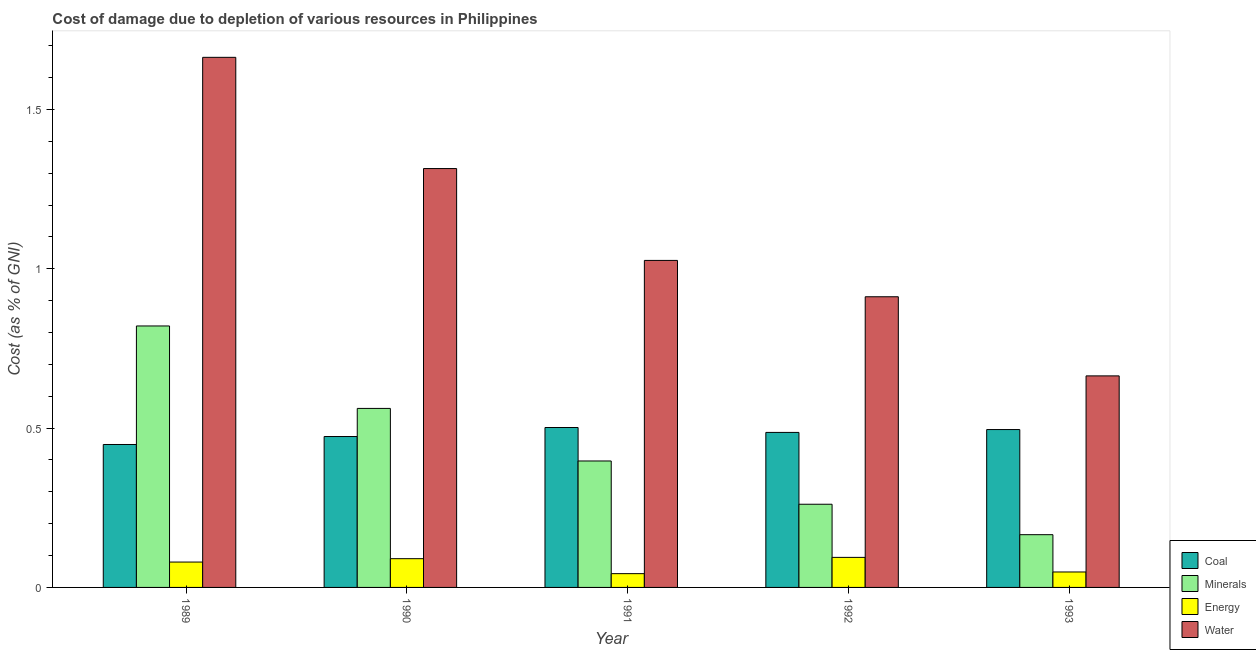How many groups of bars are there?
Your answer should be compact. 5. Are the number of bars per tick equal to the number of legend labels?
Offer a very short reply. Yes. How many bars are there on the 2nd tick from the left?
Ensure brevity in your answer.  4. What is the label of the 1st group of bars from the left?
Provide a succinct answer. 1989. What is the cost of damage due to depletion of energy in 1989?
Provide a succinct answer. 0.08. Across all years, what is the maximum cost of damage due to depletion of minerals?
Offer a very short reply. 0.82. Across all years, what is the minimum cost of damage due to depletion of energy?
Offer a very short reply. 0.04. What is the total cost of damage due to depletion of coal in the graph?
Give a very brief answer. 2.41. What is the difference between the cost of damage due to depletion of coal in 1989 and that in 1993?
Give a very brief answer. -0.05. What is the difference between the cost of damage due to depletion of water in 1992 and the cost of damage due to depletion of coal in 1989?
Keep it short and to the point. -0.75. What is the average cost of damage due to depletion of coal per year?
Give a very brief answer. 0.48. What is the ratio of the cost of damage due to depletion of water in 1991 to that in 1992?
Your answer should be very brief. 1.13. Is the cost of damage due to depletion of water in 1989 less than that in 1992?
Offer a very short reply. No. Is the difference between the cost of damage due to depletion of coal in 1990 and 1992 greater than the difference between the cost of damage due to depletion of energy in 1990 and 1992?
Offer a terse response. No. What is the difference between the highest and the second highest cost of damage due to depletion of coal?
Keep it short and to the point. 0.01. What is the difference between the highest and the lowest cost of damage due to depletion of water?
Provide a succinct answer. 1. In how many years, is the cost of damage due to depletion of minerals greater than the average cost of damage due to depletion of minerals taken over all years?
Give a very brief answer. 2. What does the 1st bar from the left in 1990 represents?
Offer a very short reply. Coal. What does the 4th bar from the right in 1992 represents?
Give a very brief answer. Coal. Is it the case that in every year, the sum of the cost of damage due to depletion of coal and cost of damage due to depletion of minerals is greater than the cost of damage due to depletion of energy?
Offer a very short reply. Yes. How many years are there in the graph?
Keep it short and to the point. 5. Does the graph contain grids?
Provide a succinct answer. No. How many legend labels are there?
Offer a very short reply. 4. How are the legend labels stacked?
Give a very brief answer. Vertical. What is the title of the graph?
Your answer should be very brief. Cost of damage due to depletion of various resources in Philippines . Does "Switzerland" appear as one of the legend labels in the graph?
Provide a succinct answer. No. What is the label or title of the X-axis?
Your answer should be compact. Year. What is the label or title of the Y-axis?
Your answer should be compact. Cost (as % of GNI). What is the Cost (as % of GNI) of Coal in 1989?
Your response must be concise. 0.45. What is the Cost (as % of GNI) of Minerals in 1989?
Make the answer very short. 0.82. What is the Cost (as % of GNI) in Energy in 1989?
Offer a very short reply. 0.08. What is the Cost (as % of GNI) of Water in 1989?
Provide a short and direct response. 1.66. What is the Cost (as % of GNI) of Coal in 1990?
Your response must be concise. 0.47. What is the Cost (as % of GNI) in Minerals in 1990?
Ensure brevity in your answer.  0.56. What is the Cost (as % of GNI) of Energy in 1990?
Ensure brevity in your answer.  0.09. What is the Cost (as % of GNI) of Water in 1990?
Offer a terse response. 1.31. What is the Cost (as % of GNI) in Coal in 1991?
Offer a very short reply. 0.5. What is the Cost (as % of GNI) in Minerals in 1991?
Provide a succinct answer. 0.4. What is the Cost (as % of GNI) in Energy in 1991?
Make the answer very short. 0.04. What is the Cost (as % of GNI) of Water in 1991?
Ensure brevity in your answer.  1.03. What is the Cost (as % of GNI) of Coal in 1992?
Ensure brevity in your answer.  0.49. What is the Cost (as % of GNI) in Minerals in 1992?
Provide a succinct answer. 0.26. What is the Cost (as % of GNI) in Energy in 1992?
Give a very brief answer. 0.09. What is the Cost (as % of GNI) of Water in 1992?
Your response must be concise. 0.91. What is the Cost (as % of GNI) of Coal in 1993?
Offer a terse response. 0.5. What is the Cost (as % of GNI) of Minerals in 1993?
Make the answer very short. 0.17. What is the Cost (as % of GNI) in Energy in 1993?
Offer a very short reply. 0.05. What is the Cost (as % of GNI) of Water in 1993?
Ensure brevity in your answer.  0.66. Across all years, what is the maximum Cost (as % of GNI) in Coal?
Offer a very short reply. 0.5. Across all years, what is the maximum Cost (as % of GNI) in Minerals?
Provide a succinct answer. 0.82. Across all years, what is the maximum Cost (as % of GNI) in Energy?
Make the answer very short. 0.09. Across all years, what is the maximum Cost (as % of GNI) in Water?
Offer a very short reply. 1.66. Across all years, what is the minimum Cost (as % of GNI) in Coal?
Your answer should be very brief. 0.45. Across all years, what is the minimum Cost (as % of GNI) in Minerals?
Make the answer very short. 0.17. Across all years, what is the minimum Cost (as % of GNI) in Energy?
Your response must be concise. 0.04. Across all years, what is the minimum Cost (as % of GNI) of Water?
Keep it short and to the point. 0.66. What is the total Cost (as % of GNI) in Coal in the graph?
Offer a terse response. 2.41. What is the total Cost (as % of GNI) in Minerals in the graph?
Offer a very short reply. 2.21. What is the total Cost (as % of GNI) of Energy in the graph?
Offer a very short reply. 0.36. What is the total Cost (as % of GNI) in Water in the graph?
Provide a short and direct response. 5.58. What is the difference between the Cost (as % of GNI) in Coal in 1989 and that in 1990?
Your answer should be very brief. -0.03. What is the difference between the Cost (as % of GNI) in Minerals in 1989 and that in 1990?
Provide a succinct answer. 0.26. What is the difference between the Cost (as % of GNI) of Energy in 1989 and that in 1990?
Keep it short and to the point. -0.01. What is the difference between the Cost (as % of GNI) of Water in 1989 and that in 1990?
Make the answer very short. 0.35. What is the difference between the Cost (as % of GNI) of Coal in 1989 and that in 1991?
Your answer should be compact. -0.05. What is the difference between the Cost (as % of GNI) in Minerals in 1989 and that in 1991?
Your answer should be compact. 0.42. What is the difference between the Cost (as % of GNI) in Energy in 1989 and that in 1991?
Your answer should be very brief. 0.04. What is the difference between the Cost (as % of GNI) in Water in 1989 and that in 1991?
Keep it short and to the point. 0.64. What is the difference between the Cost (as % of GNI) in Coal in 1989 and that in 1992?
Give a very brief answer. -0.04. What is the difference between the Cost (as % of GNI) in Minerals in 1989 and that in 1992?
Offer a terse response. 0.56. What is the difference between the Cost (as % of GNI) in Energy in 1989 and that in 1992?
Offer a terse response. -0.01. What is the difference between the Cost (as % of GNI) of Water in 1989 and that in 1992?
Offer a terse response. 0.75. What is the difference between the Cost (as % of GNI) in Coal in 1989 and that in 1993?
Provide a succinct answer. -0.05. What is the difference between the Cost (as % of GNI) of Minerals in 1989 and that in 1993?
Offer a terse response. 0.66. What is the difference between the Cost (as % of GNI) of Energy in 1989 and that in 1993?
Offer a very short reply. 0.03. What is the difference between the Cost (as % of GNI) of Water in 1989 and that in 1993?
Offer a very short reply. 1. What is the difference between the Cost (as % of GNI) in Coal in 1990 and that in 1991?
Your response must be concise. -0.03. What is the difference between the Cost (as % of GNI) in Minerals in 1990 and that in 1991?
Ensure brevity in your answer.  0.17. What is the difference between the Cost (as % of GNI) of Energy in 1990 and that in 1991?
Your answer should be compact. 0.05. What is the difference between the Cost (as % of GNI) in Water in 1990 and that in 1991?
Provide a succinct answer. 0.29. What is the difference between the Cost (as % of GNI) of Coal in 1990 and that in 1992?
Provide a succinct answer. -0.01. What is the difference between the Cost (as % of GNI) of Minerals in 1990 and that in 1992?
Provide a short and direct response. 0.3. What is the difference between the Cost (as % of GNI) of Energy in 1990 and that in 1992?
Ensure brevity in your answer.  -0. What is the difference between the Cost (as % of GNI) in Water in 1990 and that in 1992?
Offer a very short reply. 0.4. What is the difference between the Cost (as % of GNI) of Coal in 1990 and that in 1993?
Make the answer very short. -0.02. What is the difference between the Cost (as % of GNI) in Minerals in 1990 and that in 1993?
Ensure brevity in your answer.  0.4. What is the difference between the Cost (as % of GNI) in Energy in 1990 and that in 1993?
Offer a very short reply. 0.04. What is the difference between the Cost (as % of GNI) of Water in 1990 and that in 1993?
Provide a succinct answer. 0.65. What is the difference between the Cost (as % of GNI) in Coal in 1991 and that in 1992?
Provide a succinct answer. 0.02. What is the difference between the Cost (as % of GNI) in Minerals in 1991 and that in 1992?
Give a very brief answer. 0.14. What is the difference between the Cost (as % of GNI) in Energy in 1991 and that in 1992?
Ensure brevity in your answer.  -0.05. What is the difference between the Cost (as % of GNI) in Water in 1991 and that in 1992?
Make the answer very short. 0.11. What is the difference between the Cost (as % of GNI) of Coal in 1991 and that in 1993?
Your response must be concise. 0.01. What is the difference between the Cost (as % of GNI) of Minerals in 1991 and that in 1993?
Your response must be concise. 0.23. What is the difference between the Cost (as % of GNI) in Energy in 1991 and that in 1993?
Make the answer very short. -0.01. What is the difference between the Cost (as % of GNI) in Water in 1991 and that in 1993?
Offer a terse response. 0.36. What is the difference between the Cost (as % of GNI) in Coal in 1992 and that in 1993?
Keep it short and to the point. -0.01. What is the difference between the Cost (as % of GNI) of Minerals in 1992 and that in 1993?
Your answer should be very brief. 0.1. What is the difference between the Cost (as % of GNI) of Energy in 1992 and that in 1993?
Provide a succinct answer. 0.05. What is the difference between the Cost (as % of GNI) in Water in 1992 and that in 1993?
Provide a short and direct response. 0.25. What is the difference between the Cost (as % of GNI) of Coal in 1989 and the Cost (as % of GNI) of Minerals in 1990?
Provide a succinct answer. -0.11. What is the difference between the Cost (as % of GNI) in Coal in 1989 and the Cost (as % of GNI) in Energy in 1990?
Offer a very short reply. 0.36. What is the difference between the Cost (as % of GNI) in Coal in 1989 and the Cost (as % of GNI) in Water in 1990?
Keep it short and to the point. -0.87. What is the difference between the Cost (as % of GNI) in Minerals in 1989 and the Cost (as % of GNI) in Energy in 1990?
Provide a short and direct response. 0.73. What is the difference between the Cost (as % of GNI) of Minerals in 1989 and the Cost (as % of GNI) of Water in 1990?
Your answer should be very brief. -0.49. What is the difference between the Cost (as % of GNI) of Energy in 1989 and the Cost (as % of GNI) of Water in 1990?
Give a very brief answer. -1.24. What is the difference between the Cost (as % of GNI) in Coal in 1989 and the Cost (as % of GNI) in Minerals in 1991?
Make the answer very short. 0.05. What is the difference between the Cost (as % of GNI) of Coal in 1989 and the Cost (as % of GNI) of Energy in 1991?
Your response must be concise. 0.41. What is the difference between the Cost (as % of GNI) in Coal in 1989 and the Cost (as % of GNI) in Water in 1991?
Your answer should be compact. -0.58. What is the difference between the Cost (as % of GNI) in Minerals in 1989 and the Cost (as % of GNI) in Energy in 1991?
Your answer should be very brief. 0.78. What is the difference between the Cost (as % of GNI) of Minerals in 1989 and the Cost (as % of GNI) of Water in 1991?
Provide a short and direct response. -0.21. What is the difference between the Cost (as % of GNI) in Energy in 1989 and the Cost (as % of GNI) in Water in 1991?
Your answer should be compact. -0.95. What is the difference between the Cost (as % of GNI) of Coal in 1989 and the Cost (as % of GNI) of Minerals in 1992?
Make the answer very short. 0.19. What is the difference between the Cost (as % of GNI) in Coal in 1989 and the Cost (as % of GNI) in Energy in 1992?
Make the answer very short. 0.35. What is the difference between the Cost (as % of GNI) in Coal in 1989 and the Cost (as % of GNI) in Water in 1992?
Make the answer very short. -0.46. What is the difference between the Cost (as % of GNI) in Minerals in 1989 and the Cost (as % of GNI) in Energy in 1992?
Ensure brevity in your answer.  0.73. What is the difference between the Cost (as % of GNI) in Minerals in 1989 and the Cost (as % of GNI) in Water in 1992?
Your answer should be compact. -0.09. What is the difference between the Cost (as % of GNI) in Energy in 1989 and the Cost (as % of GNI) in Water in 1992?
Make the answer very short. -0.83. What is the difference between the Cost (as % of GNI) of Coal in 1989 and the Cost (as % of GNI) of Minerals in 1993?
Provide a succinct answer. 0.28. What is the difference between the Cost (as % of GNI) in Coal in 1989 and the Cost (as % of GNI) in Energy in 1993?
Your answer should be very brief. 0.4. What is the difference between the Cost (as % of GNI) in Coal in 1989 and the Cost (as % of GNI) in Water in 1993?
Offer a terse response. -0.22. What is the difference between the Cost (as % of GNI) in Minerals in 1989 and the Cost (as % of GNI) in Energy in 1993?
Offer a very short reply. 0.77. What is the difference between the Cost (as % of GNI) in Minerals in 1989 and the Cost (as % of GNI) in Water in 1993?
Your response must be concise. 0.16. What is the difference between the Cost (as % of GNI) of Energy in 1989 and the Cost (as % of GNI) of Water in 1993?
Make the answer very short. -0.58. What is the difference between the Cost (as % of GNI) in Coal in 1990 and the Cost (as % of GNI) in Minerals in 1991?
Your response must be concise. 0.08. What is the difference between the Cost (as % of GNI) in Coal in 1990 and the Cost (as % of GNI) in Energy in 1991?
Your answer should be compact. 0.43. What is the difference between the Cost (as % of GNI) of Coal in 1990 and the Cost (as % of GNI) of Water in 1991?
Offer a terse response. -0.55. What is the difference between the Cost (as % of GNI) in Minerals in 1990 and the Cost (as % of GNI) in Energy in 1991?
Offer a very short reply. 0.52. What is the difference between the Cost (as % of GNI) in Minerals in 1990 and the Cost (as % of GNI) in Water in 1991?
Make the answer very short. -0.46. What is the difference between the Cost (as % of GNI) of Energy in 1990 and the Cost (as % of GNI) of Water in 1991?
Your answer should be compact. -0.94. What is the difference between the Cost (as % of GNI) in Coal in 1990 and the Cost (as % of GNI) in Minerals in 1992?
Provide a succinct answer. 0.21. What is the difference between the Cost (as % of GNI) of Coal in 1990 and the Cost (as % of GNI) of Energy in 1992?
Your answer should be compact. 0.38. What is the difference between the Cost (as % of GNI) in Coal in 1990 and the Cost (as % of GNI) in Water in 1992?
Provide a short and direct response. -0.44. What is the difference between the Cost (as % of GNI) of Minerals in 1990 and the Cost (as % of GNI) of Energy in 1992?
Provide a succinct answer. 0.47. What is the difference between the Cost (as % of GNI) of Minerals in 1990 and the Cost (as % of GNI) of Water in 1992?
Give a very brief answer. -0.35. What is the difference between the Cost (as % of GNI) of Energy in 1990 and the Cost (as % of GNI) of Water in 1992?
Offer a very short reply. -0.82. What is the difference between the Cost (as % of GNI) of Coal in 1990 and the Cost (as % of GNI) of Minerals in 1993?
Your answer should be very brief. 0.31. What is the difference between the Cost (as % of GNI) of Coal in 1990 and the Cost (as % of GNI) of Energy in 1993?
Your answer should be very brief. 0.43. What is the difference between the Cost (as % of GNI) of Coal in 1990 and the Cost (as % of GNI) of Water in 1993?
Keep it short and to the point. -0.19. What is the difference between the Cost (as % of GNI) of Minerals in 1990 and the Cost (as % of GNI) of Energy in 1993?
Offer a terse response. 0.51. What is the difference between the Cost (as % of GNI) in Minerals in 1990 and the Cost (as % of GNI) in Water in 1993?
Give a very brief answer. -0.1. What is the difference between the Cost (as % of GNI) of Energy in 1990 and the Cost (as % of GNI) of Water in 1993?
Offer a terse response. -0.57. What is the difference between the Cost (as % of GNI) in Coal in 1991 and the Cost (as % of GNI) in Minerals in 1992?
Offer a terse response. 0.24. What is the difference between the Cost (as % of GNI) in Coal in 1991 and the Cost (as % of GNI) in Energy in 1992?
Offer a terse response. 0.41. What is the difference between the Cost (as % of GNI) of Coal in 1991 and the Cost (as % of GNI) of Water in 1992?
Offer a very short reply. -0.41. What is the difference between the Cost (as % of GNI) in Minerals in 1991 and the Cost (as % of GNI) in Energy in 1992?
Your response must be concise. 0.3. What is the difference between the Cost (as % of GNI) in Minerals in 1991 and the Cost (as % of GNI) in Water in 1992?
Your answer should be very brief. -0.52. What is the difference between the Cost (as % of GNI) of Energy in 1991 and the Cost (as % of GNI) of Water in 1992?
Keep it short and to the point. -0.87. What is the difference between the Cost (as % of GNI) of Coal in 1991 and the Cost (as % of GNI) of Minerals in 1993?
Offer a very short reply. 0.34. What is the difference between the Cost (as % of GNI) of Coal in 1991 and the Cost (as % of GNI) of Energy in 1993?
Your response must be concise. 0.45. What is the difference between the Cost (as % of GNI) in Coal in 1991 and the Cost (as % of GNI) in Water in 1993?
Make the answer very short. -0.16. What is the difference between the Cost (as % of GNI) in Minerals in 1991 and the Cost (as % of GNI) in Energy in 1993?
Your answer should be very brief. 0.35. What is the difference between the Cost (as % of GNI) in Minerals in 1991 and the Cost (as % of GNI) in Water in 1993?
Ensure brevity in your answer.  -0.27. What is the difference between the Cost (as % of GNI) in Energy in 1991 and the Cost (as % of GNI) in Water in 1993?
Your response must be concise. -0.62. What is the difference between the Cost (as % of GNI) of Coal in 1992 and the Cost (as % of GNI) of Minerals in 1993?
Provide a short and direct response. 0.32. What is the difference between the Cost (as % of GNI) of Coal in 1992 and the Cost (as % of GNI) of Energy in 1993?
Offer a very short reply. 0.44. What is the difference between the Cost (as % of GNI) of Coal in 1992 and the Cost (as % of GNI) of Water in 1993?
Offer a very short reply. -0.18. What is the difference between the Cost (as % of GNI) in Minerals in 1992 and the Cost (as % of GNI) in Energy in 1993?
Ensure brevity in your answer.  0.21. What is the difference between the Cost (as % of GNI) in Minerals in 1992 and the Cost (as % of GNI) in Water in 1993?
Give a very brief answer. -0.4. What is the difference between the Cost (as % of GNI) of Energy in 1992 and the Cost (as % of GNI) of Water in 1993?
Keep it short and to the point. -0.57. What is the average Cost (as % of GNI) in Coal per year?
Provide a succinct answer. 0.48. What is the average Cost (as % of GNI) in Minerals per year?
Offer a terse response. 0.44. What is the average Cost (as % of GNI) in Energy per year?
Your answer should be compact. 0.07. What is the average Cost (as % of GNI) in Water per year?
Provide a short and direct response. 1.12. In the year 1989, what is the difference between the Cost (as % of GNI) of Coal and Cost (as % of GNI) of Minerals?
Your answer should be compact. -0.37. In the year 1989, what is the difference between the Cost (as % of GNI) of Coal and Cost (as % of GNI) of Energy?
Ensure brevity in your answer.  0.37. In the year 1989, what is the difference between the Cost (as % of GNI) in Coal and Cost (as % of GNI) in Water?
Provide a short and direct response. -1.22. In the year 1989, what is the difference between the Cost (as % of GNI) of Minerals and Cost (as % of GNI) of Energy?
Offer a very short reply. 0.74. In the year 1989, what is the difference between the Cost (as % of GNI) in Minerals and Cost (as % of GNI) in Water?
Offer a very short reply. -0.84. In the year 1989, what is the difference between the Cost (as % of GNI) of Energy and Cost (as % of GNI) of Water?
Your answer should be compact. -1.58. In the year 1990, what is the difference between the Cost (as % of GNI) in Coal and Cost (as % of GNI) in Minerals?
Offer a very short reply. -0.09. In the year 1990, what is the difference between the Cost (as % of GNI) in Coal and Cost (as % of GNI) in Energy?
Your answer should be very brief. 0.38. In the year 1990, what is the difference between the Cost (as % of GNI) of Coal and Cost (as % of GNI) of Water?
Keep it short and to the point. -0.84. In the year 1990, what is the difference between the Cost (as % of GNI) in Minerals and Cost (as % of GNI) in Energy?
Your answer should be compact. 0.47. In the year 1990, what is the difference between the Cost (as % of GNI) in Minerals and Cost (as % of GNI) in Water?
Give a very brief answer. -0.75. In the year 1990, what is the difference between the Cost (as % of GNI) of Energy and Cost (as % of GNI) of Water?
Your answer should be compact. -1.22. In the year 1991, what is the difference between the Cost (as % of GNI) of Coal and Cost (as % of GNI) of Minerals?
Make the answer very short. 0.11. In the year 1991, what is the difference between the Cost (as % of GNI) of Coal and Cost (as % of GNI) of Energy?
Offer a very short reply. 0.46. In the year 1991, what is the difference between the Cost (as % of GNI) in Coal and Cost (as % of GNI) in Water?
Your answer should be very brief. -0.52. In the year 1991, what is the difference between the Cost (as % of GNI) of Minerals and Cost (as % of GNI) of Energy?
Make the answer very short. 0.35. In the year 1991, what is the difference between the Cost (as % of GNI) of Minerals and Cost (as % of GNI) of Water?
Provide a short and direct response. -0.63. In the year 1991, what is the difference between the Cost (as % of GNI) of Energy and Cost (as % of GNI) of Water?
Offer a terse response. -0.98. In the year 1992, what is the difference between the Cost (as % of GNI) of Coal and Cost (as % of GNI) of Minerals?
Offer a very short reply. 0.23. In the year 1992, what is the difference between the Cost (as % of GNI) of Coal and Cost (as % of GNI) of Energy?
Give a very brief answer. 0.39. In the year 1992, what is the difference between the Cost (as % of GNI) in Coal and Cost (as % of GNI) in Water?
Your answer should be compact. -0.43. In the year 1992, what is the difference between the Cost (as % of GNI) of Minerals and Cost (as % of GNI) of Energy?
Make the answer very short. 0.17. In the year 1992, what is the difference between the Cost (as % of GNI) in Minerals and Cost (as % of GNI) in Water?
Your response must be concise. -0.65. In the year 1992, what is the difference between the Cost (as % of GNI) of Energy and Cost (as % of GNI) of Water?
Your response must be concise. -0.82. In the year 1993, what is the difference between the Cost (as % of GNI) of Coal and Cost (as % of GNI) of Minerals?
Provide a succinct answer. 0.33. In the year 1993, what is the difference between the Cost (as % of GNI) of Coal and Cost (as % of GNI) of Energy?
Provide a succinct answer. 0.45. In the year 1993, what is the difference between the Cost (as % of GNI) of Coal and Cost (as % of GNI) of Water?
Give a very brief answer. -0.17. In the year 1993, what is the difference between the Cost (as % of GNI) in Minerals and Cost (as % of GNI) in Energy?
Keep it short and to the point. 0.12. In the year 1993, what is the difference between the Cost (as % of GNI) in Minerals and Cost (as % of GNI) in Water?
Make the answer very short. -0.5. In the year 1993, what is the difference between the Cost (as % of GNI) in Energy and Cost (as % of GNI) in Water?
Your answer should be compact. -0.62. What is the ratio of the Cost (as % of GNI) in Coal in 1989 to that in 1990?
Keep it short and to the point. 0.95. What is the ratio of the Cost (as % of GNI) of Minerals in 1989 to that in 1990?
Offer a very short reply. 1.46. What is the ratio of the Cost (as % of GNI) in Energy in 1989 to that in 1990?
Your answer should be compact. 0.88. What is the ratio of the Cost (as % of GNI) in Water in 1989 to that in 1990?
Your answer should be compact. 1.27. What is the ratio of the Cost (as % of GNI) in Coal in 1989 to that in 1991?
Keep it short and to the point. 0.89. What is the ratio of the Cost (as % of GNI) in Minerals in 1989 to that in 1991?
Provide a succinct answer. 2.07. What is the ratio of the Cost (as % of GNI) of Energy in 1989 to that in 1991?
Give a very brief answer. 1.84. What is the ratio of the Cost (as % of GNI) in Water in 1989 to that in 1991?
Your answer should be very brief. 1.62. What is the ratio of the Cost (as % of GNI) in Coal in 1989 to that in 1992?
Provide a short and direct response. 0.92. What is the ratio of the Cost (as % of GNI) of Minerals in 1989 to that in 1992?
Keep it short and to the point. 3.14. What is the ratio of the Cost (as % of GNI) in Energy in 1989 to that in 1992?
Ensure brevity in your answer.  0.84. What is the ratio of the Cost (as % of GNI) of Water in 1989 to that in 1992?
Offer a very short reply. 1.82. What is the ratio of the Cost (as % of GNI) in Coal in 1989 to that in 1993?
Your answer should be very brief. 0.91. What is the ratio of the Cost (as % of GNI) in Minerals in 1989 to that in 1993?
Ensure brevity in your answer.  4.96. What is the ratio of the Cost (as % of GNI) in Energy in 1989 to that in 1993?
Your answer should be very brief. 1.64. What is the ratio of the Cost (as % of GNI) of Water in 1989 to that in 1993?
Make the answer very short. 2.51. What is the ratio of the Cost (as % of GNI) of Coal in 1990 to that in 1991?
Provide a short and direct response. 0.94. What is the ratio of the Cost (as % of GNI) in Minerals in 1990 to that in 1991?
Offer a very short reply. 1.42. What is the ratio of the Cost (as % of GNI) of Energy in 1990 to that in 1991?
Provide a short and direct response. 2.09. What is the ratio of the Cost (as % of GNI) of Water in 1990 to that in 1991?
Your answer should be very brief. 1.28. What is the ratio of the Cost (as % of GNI) in Coal in 1990 to that in 1992?
Provide a succinct answer. 0.97. What is the ratio of the Cost (as % of GNI) of Minerals in 1990 to that in 1992?
Give a very brief answer. 2.15. What is the ratio of the Cost (as % of GNI) in Energy in 1990 to that in 1992?
Your answer should be compact. 0.96. What is the ratio of the Cost (as % of GNI) in Water in 1990 to that in 1992?
Offer a terse response. 1.44. What is the ratio of the Cost (as % of GNI) in Coal in 1990 to that in 1993?
Provide a short and direct response. 0.96. What is the ratio of the Cost (as % of GNI) of Minerals in 1990 to that in 1993?
Provide a short and direct response. 3.39. What is the ratio of the Cost (as % of GNI) in Energy in 1990 to that in 1993?
Provide a succinct answer. 1.86. What is the ratio of the Cost (as % of GNI) in Water in 1990 to that in 1993?
Keep it short and to the point. 1.98. What is the ratio of the Cost (as % of GNI) in Coal in 1991 to that in 1992?
Offer a terse response. 1.03. What is the ratio of the Cost (as % of GNI) of Minerals in 1991 to that in 1992?
Offer a very short reply. 1.52. What is the ratio of the Cost (as % of GNI) in Energy in 1991 to that in 1992?
Provide a succinct answer. 0.46. What is the ratio of the Cost (as % of GNI) of Water in 1991 to that in 1992?
Ensure brevity in your answer.  1.12. What is the ratio of the Cost (as % of GNI) of Minerals in 1991 to that in 1993?
Offer a very short reply. 2.4. What is the ratio of the Cost (as % of GNI) in Energy in 1991 to that in 1993?
Keep it short and to the point. 0.89. What is the ratio of the Cost (as % of GNI) in Water in 1991 to that in 1993?
Give a very brief answer. 1.55. What is the ratio of the Cost (as % of GNI) of Coal in 1992 to that in 1993?
Offer a terse response. 0.98. What is the ratio of the Cost (as % of GNI) in Minerals in 1992 to that in 1993?
Your answer should be compact. 1.58. What is the ratio of the Cost (as % of GNI) in Energy in 1992 to that in 1993?
Keep it short and to the point. 1.95. What is the ratio of the Cost (as % of GNI) in Water in 1992 to that in 1993?
Ensure brevity in your answer.  1.37. What is the difference between the highest and the second highest Cost (as % of GNI) in Coal?
Offer a terse response. 0.01. What is the difference between the highest and the second highest Cost (as % of GNI) in Minerals?
Provide a short and direct response. 0.26. What is the difference between the highest and the second highest Cost (as % of GNI) in Energy?
Your response must be concise. 0. What is the difference between the highest and the second highest Cost (as % of GNI) in Water?
Keep it short and to the point. 0.35. What is the difference between the highest and the lowest Cost (as % of GNI) of Coal?
Offer a very short reply. 0.05. What is the difference between the highest and the lowest Cost (as % of GNI) of Minerals?
Provide a short and direct response. 0.66. What is the difference between the highest and the lowest Cost (as % of GNI) of Energy?
Provide a short and direct response. 0.05. 